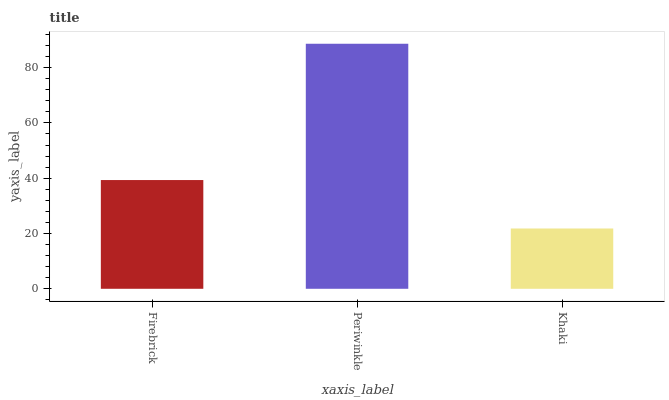Is Khaki the minimum?
Answer yes or no. Yes. Is Periwinkle the maximum?
Answer yes or no. Yes. Is Periwinkle the minimum?
Answer yes or no. No. Is Khaki the maximum?
Answer yes or no. No. Is Periwinkle greater than Khaki?
Answer yes or no. Yes. Is Khaki less than Periwinkle?
Answer yes or no. Yes. Is Khaki greater than Periwinkle?
Answer yes or no. No. Is Periwinkle less than Khaki?
Answer yes or no. No. Is Firebrick the high median?
Answer yes or no. Yes. Is Firebrick the low median?
Answer yes or no. Yes. Is Khaki the high median?
Answer yes or no. No. Is Khaki the low median?
Answer yes or no. No. 